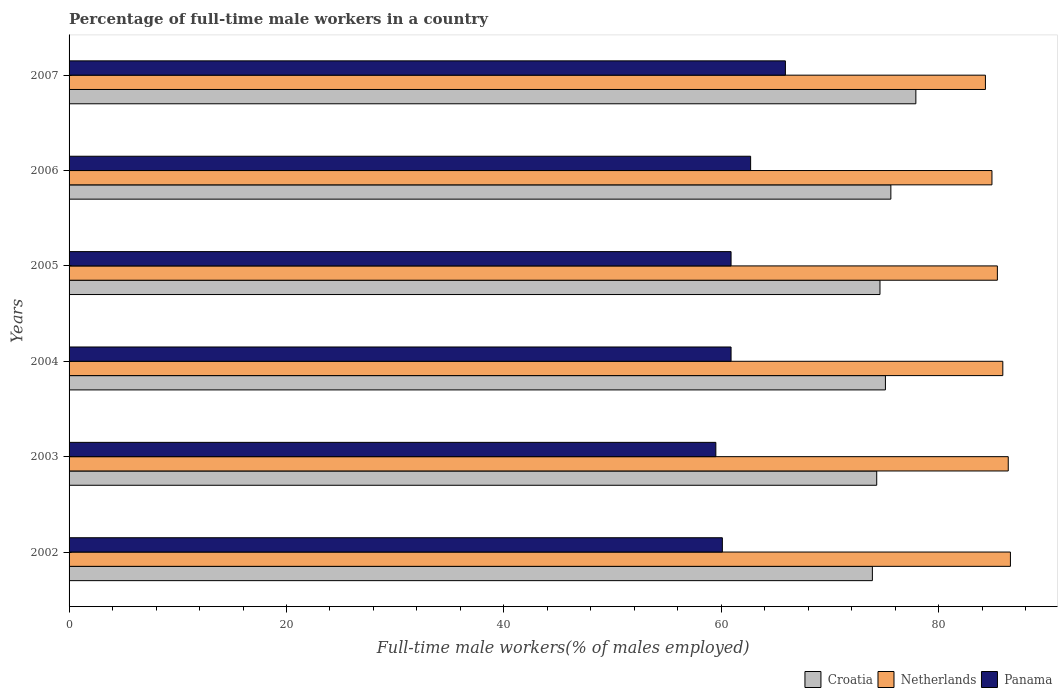How many different coloured bars are there?
Provide a short and direct response. 3. How many groups of bars are there?
Offer a very short reply. 6. Are the number of bars on each tick of the Y-axis equal?
Your answer should be very brief. Yes. How many bars are there on the 4th tick from the bottom?
Offer a terse response. 3. In how many cases, is the number of bars for a given year not equal to the number of legend labels?
Your answer should be compact. 0. What is the percentage of full-time male workers in Croatia in 2006?
Provide a succinct answer. 75.6. Across all years, what is the maximum percentage of full-time male workers in Panama?
Offer a very short reply. 65.9. Across all years, what is the minimum percentage of full-time male workers in Croatia?
Make the answer very short. 73.9. In which year was the percentage of full-time male workers in Netherlands minimum?
Give a very brief answer. 2007. What is the total percentage of full-time male workers in Croatia in the graph?
Your response must be concise. 451.4. What is the difference between the percentage of full-time male workers in Croatia in 2005 and that in 2007?
Your answer should be compact. -3.3. What is the difference between the percentage of full-time male workers in Panama in 2004 and the percentage of full-time male workers in Croatia in 2002?
Your answer should be compact. -13. What is the average percentage of full-time male workers in Croatia per year?
Make the answer very short. 75.23. In the year 2006, what is the difference between the percentage of full-time male workers in Netherlands and percentage of full-time male workers in Panama?
Your answer should be very brief. 22.2. What is the ratio of the percentage of full-time male workers in Panama in 2005 to that in 2006?
Keep it short and to the point. 0.97. Is the difference between the percentage of full-time male workers in Netherlands in 2002 and 2007 greater than the difference between the percentage of full-time male workers in Panama in 2002 and 2007?
Offer a terse response. Yes. What is the difference between the highest and the second highest percentage of full-time male workers in Croatia?
Your response must be concise. 2.3. What is the difference between the highest and the lowest percentage of full-time male workers in Netherlands?
Ensure brevity in your answer.  2.3. What does the 1st bar from the top in 2005 represents?
Your answer should be compact. Panama. What does the 3rd bar from the bottom in 2002 represents?
Your response must be concise. Panama. Is it the case that in every year, the sum of the percentage of full-time male workers in Croatia and percentage of full-time male workers in Panama is greater than the percentage of full-time male workers in Netherlands?
Give a very brief answer. Yes. How many bars are there?
Provide a short and direct response. 18. How many years are there in the graph?
Keep it short and to the point. 6. What is the difference between two consecutive major ticks on the X-axis?
Your answer should be compact. 20. Does the graph contain grids?
Provide a short and direct response. No. How are the legend labels stacked?
Keep it short and to the point. Horizontal. What is the title of the graph?
Ensure brevity in your answer.  Percentage of full-time male workers in a country. What is the label or title of the X-axis?
Provide a succinct answer. Full-time male workers(% of males employed). What is the label or title of the Y-axis?
Provide a succinct answer. Years. What is the Full-time male workers(% of males employed) in Croatia in 2002?
Your answer should be compact. 73.9. What is the Full-time male workers(% of males employed) of Netherlands in 2002?
Your answer should be compact. 86.6. What is the Full-time male workers(% of males employed) in Panama in 2002?
Keep it short and to the point. 60.1. What is the Full-time male workers(% of males employed) in Croatia in 2003?
Your response must be concise. 74.3. What is the Full-time male workers(% of males employed) of Netherlands in 2003?
Ensure brevity in your answer.  86.4. What is the Full-time male workers(% of males employed) of Panama in 2003?
Your response must be concise. 59.5. What is the Full-time male workers(% of males employed) in Croatia in 2004?
Your answer should be very brief. 75.1. What is the Full-time male workers(% of males employed) of Netherlands in 2004?
Give a very brief answer. 85.9. What is the Full-time male workers(% of males employed) in Panama in 2004?
Give a very brief answer. 60.9. What is the Full-time male workers(% of males employed) in Croatia in 2005?
Ensure brevity in your answer.  74.6. What is the Full-time male workers(% of males employed) of Netherlands in 2005?
Give a very brief answer. 85.4. What is the Full-time male workers(% of males employed) in Panama in 2005?
Make the answer very short. 60.9. What is the Full-time male workers(% of males employed) in Croatia in 2006?
Your answer should be very brief. 75.6. What is the Full-time male workers(% of males employed) in Netherlands in 2006?
Your answer should be compact. 84.9. What is the Full-time male workers(% of males employed) of Panama in 2006?
Keep it short and to the point. 62.7. What is the Full-time male workers(% of males employed) of Croatia in 2007?
Ensure brevity in your answer.  77.9. What is the Full-time male workers(% of males employed) of Netherlands in 2007?
Your response must be concise. 84.3. What is the Full-time male workers(% of males employed) of Panama in 2007?
Your answer should be very brief. 65.9. Across all years, what is the maximum Full-time male workers(% of males employed) in Croatia?
Your response must be concise. 77.9. Across all years, what is the maximum Full-time male workers(% of males employed) in Netherlands?
Provide a short and direct response. 86.6. Across all years, what is the maximum Full-time male workers(% of males employed) in Panama?
Your response must be concise. 65.9. Across all years, what is the minimum Full-time male workers(% of males employed) in Croatia?
Your answer should be compact. 73.9. Across all years, what is the minimum Full-time male workers(% of males employed) of Netherlands?
Offer a terse response. 84.3. Across all years, what is the minimum Full-time male workers(% of males employed) of Panama?
Give a very brief answer. 59.5. What is the total Full-time male workers(% of males employed) of Croatia in the graph?
Your answer should be compact. 451.4. What is the total Full-time male workers(% of males employed) of Netherlands in the graph?
Your response must be concise. 513.5. What is the total Full-time male workers(% of males employed) in Panama in the graph?
Give a very brief answer. 370. What is the difference between the Full-time male workers(% of males employed) in Netherlands in 2002 and that in 2004?
Keep it short and to the point. 0.7. What is the difference between the Full-time male workers(% of males employed) of Panama in 2002 and that in 2004?
Your answer should be very brief. -0.8. What is the difference between the Full-time male workers(% of males employed) of Croatia in 2002 and that in 2005?
Your answer should be very brief. -0.7. What is the difference between the Full-time male workers(% of males employed) of Croatia in 2002 and that in 2006?
Ensure brevity in your answer.  -1.7. What is the difference between the Full-time male workers(% of males employed) in Croatia in 2002 and that in 2007?
Your response must be concise. -4. What is the difference between the Full-time male workers(% of males employed) of Netherlands in 2002 and that in 2007?
Your answer should be compact. 2.3. What is the difference between the Full-time male workers(% of males employed) of Panama in 2002 and that in 2007?
Offer a very short reply. -5.8. What is the difference between the Full-time male workers(% of males employed) in Croatia in 2003 and that in 2004?
Keep it short and to the point. -0.8. What is the difference between the Full-time male workers(% of males employed) in Netherlands in 2003 and that in 2004?
Your response must be concise. 0.5. What is the difference between the Full-time male workers(% of males employed) of Panama in 2003 and that in 2005?
Offer a very short reply. -1.4. What is the difference between the Full-time male workers(% of males employed) in Netherlands in 2003 and that in 2007?
Ensure brevity in your answer.  2.1. What is the difference between the Full-time male workers(% of males employed) in Panama in 2003 and that in 2007?
Your answer should be compact. -6.4. What is the difference between the Full-time male workers(% of males employed) of Netherlands in 2004 and that in 2005?
Ensure brevity in your answer.  0.5. What is the difference between the Full-time male workers(% of males employed) of Netherlands in 2004 and that in 2006?
Ensure brevity in your answer.  1. What is the difference between the Full-time male workers(% of males employed) in Netherlands in 2004 and that in 2007?
Provide a succinct answer. 1.6. What is the difference between the Full-time male workers(% of males employed) of Croatia in 2005 and that in 2006?
Provide a succinct answer. -1. What is the difference between the Full-time male workers(% of males employed) of Panama in 2005 and that in 2006?
Your response must be concise. -1.8. What is the difference between the Full-time male workers(% of males employed) in Croatia in 2005 and that in 2007?
Make the answer very short. -3.3. What is the difference between the Full-time male workers(% of males employed) in Croatia in 2006 and that in 2007?
Make the answer very short. -2.3. What is the difference between the Full-time male workers(% of males employed) in Netherlands in 2006 and that in 2007?
Your response must be concise. 0.6. What is the difference between the Full-time male workers(% of males employed) of Croatia in 2002 and the Full-time male workers(% of males employed) of Netherlands in 2003?
Offer a terse response. -12.5. What is the difference between the Full-time male workers(% of males employed) of Netherlands in 2002 and the Full-time male workers(% of males employed) of Panama in 2003?
Keep it short and to the point. 27.1. What is the difference between the Full-time male workers(% of males employed) of Croatia in 2002 and the Full-time male workers(% of males employed) of Netherlands in 2004?
Provide a succinct answer. -12. What is the difference between the Full-time male workers(% of males employed) of Croatia in 2002 and the Full-time male workers(% of males employed) of Panama in 2004?
Ensure brevity in your answer.  13. What is the difference between the Full-time male workers(% of males employed) in Netherlands in 2002 and the Full-time male workers(% of males employed) in Panama in 2004?
Provide a short and direct response. 25.7. What is the difference between the Full-time male workers(% of males employed) in Croatia in 2002 and the Full-time male workers(% of males employed) in Netherlands in 2005?
Your answer should be compact. -11.5. What is the difference between the Full-time male workers(% of males employed) of Netherlands in 2002 and the Full-time male workers(% of males employed) of Panama in 2005?
Your answer should be very brief. 25.7. What is the difference between the Full-time male workers(% of males employed) in Croatia in 2002 and the Full-time male workers(% of males employed) in Panama in 2006?
Offer a very short reply. 11.2. What is the difference between the Full-time male workers(% of males employed) of Netherlands in 2002 and the Full-time male workers(% of males employed) of Panama in 2006?
Keep it short and to the point. 23.9. What is the difference between the Full-time male workers(% of males employed) of Netherlands in 2002 and the Full-time male workers(% of males employed) of Panama in 2007?
Your answer should be compact. 20.7. What is the difference between the Full-time male workers(% of males employed) of Netherlands in 2003 and the Full-time male workers(% of males employed) of Panama in 2004?
Provide a short and direct response. 25.5. What is the difference between the Full-time male workers(% of males employed) of Netherlands in 2003 and the Full-time male workers(% of males employed) of Panama in 2005?
Provide a short and direct response. 25.5. What is the difference between the Full-time male workers(% of males employed) in Croatia in 2003 and the Full-time male workers(% of males employed) in Netherlands in 2006?
Your response must be concise. -10.6. What is the difference between the Full-time male workers(% of males employed) in Croatia in 2003 and the Full-time male workers(% of males employed) in Panama in 2006?
Provide a short and direct response. 11.6. What is the difference between the Full-time male workers(% of males employed) in Netherlands in 2003 and the Full-time male workers(% of males employed) in Panama in 2006?
Provide a short and direct response. 23.7. What is the difference between the Full-time male workers(% of males employed) of Croatia in 2003 and the Full-time male workers(% of males employed) of Netherlands in 2007?
Ensure brevity in your answer.  -10. What is the difference between the Full-time male workers(% of males employed) of Netherlands in 2004 and the Full-time male workers(% of males employed) of Panama in 2005?
Provide a succinct answer. 25. What is the difference between the Full-time male workers(% of males employed) of Croatia in 2004 and the Full-time male workers(% of males employed) of Netherlands in 2006?
Keep it short and to the point. -9.8. What is the difference between the Full-time male workers(% of males employed) of Netherlands in 2004 and the Full-time male workers(% of males employed) of Panama in 2006?
Your answer should be compact. 23.2. What is the difference between the Full-time male workers(% of males employed) of Croatia in 2004 and the Full-time male workers(% of males employed) of Netherlands in 2007?
Your answer should be compact. -9.2. What is the difference between the Full-time male workers(% of males employed) of Netherlands in 2005 and the Full-time male workers(% of males employed) of Panama in 2006?
Provide a succinct answer. 22.7. What is the difference between the Full-time male workers(% of males employed) of Croatia in 2005 and the Full-time male workers(% of males employed) of Panama in 2007?
Offer a very short reply. 8.7. What is the difference between the Full-time male workers(% of males employed) of Netherlands in 2005 and the Full-time male workers(% of males employed) of Panama in 2007?
Make the answer very short. 19.5. What is the difference between the Full-time male workers(% of males employed) in Croatia in 2006 and the Full-time male workers(% of males employed) in Netherlands in 2007?
Your response must be concise. -8.7. What is the difference between the Full-time male workers(% of males employed) of Croatia in 2006 and the Full-time male workers(% of males employed) of Panama in 2007?
Ensure brevity in your answer.  9.7. What is the average Full-time male workers(% of males employed) of Croatia per year?
Offer a very short reply. 75.23. What is the average Full-time male workers(% of males employed) in Netherlands per year?
Your response must be concise. 85.58. What is the average Full-time male workers(% of males employed) in Panama per year?
Offer a terse response. 61.67. In the year 2003, what is the difference between the Full-time male workers(% of males employed) of Croatia and Full-time male workers(% of males employed) of Netherlands?
Offer a very short reply. -12.1. In the year 2003, what is the difference between the Full-time male workers(% of males employed) in Croatia and Full-time male workers(% of males employed) in Panama?
Your response must be concise. 14.8. In the year 2003, what is the difference between the Full-time male workers(% of males employed) in Netherlands and Full-time male workers(% of males employed) in Panama?
Provide a succinct answer. 26.9. In the year 2004, what is the difference between the Full-time male workers(% of males employed) of Croatia and Full-time male workers(% of males employed) of Netherlands?
Give a very brief answer. -10.8. In the year 2004, what is the difference between the Full-time male workers(% of males employed) in Netherlands and Full-time male workers(% of males employed) in Panama?
Your response must be concise. 25. In the year 2005, what is the difference between the Full-time male workers(% of males employed) in Croatia and Full-time male workers(% of males employed) in Panama?
Offer a terse response. 13.7. In the year 2005, what is the difference between the Full-time male workers(% of males employed) of Netherlands and Full-time male workers(% of males employed) of Panama?
Provide a short and direct response. 24.5. In the year 2006, what is the difference between the Full-time male workers(% of males employed) in Netherlands and Full-time male workers(% of males employed) in Panama?
Provide a short and direct response. 22.2. In the year 2007, what is the difference between the Full-time male workers(% of males employed) of Croatia and Full-time male workers(% of males employed) of Panama?
Make the answer very short. 12. In the year 2007, what is the difference between the Full-time male workers(% of males employed) of Netherlands and Full-time male workers(% of males employed) of Panama?
Offer a very short reply. 18.4. What is the ratio of the Full-time male workers(% of males employed) of Netherlands in 2002 to that in 2003?
Your answer should be compact. 1. What is the ratio of the Full-time male workers(% of males employed) of Panama in 2002 to that in 2003?
Offer a very short reply. 1.01. What is the ratio of the Full-time male workers(% of males employed) of Croatia in 2002 to that in 2004?
Make the answer very short. 0.98. What is the ratio of the Full-time male workers(% of males employed) of Panama in 2002 to that in 2004?
Your answer should be compact. 0.99. What is the ratio of the Full-time male workers(% of males employed) in Croatia in 2002 to that in 2005?
Keep it short and to the point. 0.99. What is the ratio of the Full-time male workers(% of males employed) in Netherlands in 2002 to that in 2005?
Keep it short and to the point. 1.01. What is the ratio of the Full-time male workers(% of males employed) of Panama in 2002 to that in 2005?
Your answer should be compact. 0.99. What is the ratio of the Full-time male workers(% of males employed) of Croatia in 2002 to that in 2006?
Make the answer very short. 0.98. What is the ratio of the Full-time male workers(% of males employed) of Panama in 2002 to that in 2006?
Offer a terse response. 0.96. What is the ratio of the Full-time male workers(% of males employed) of Croatia in 2002 to that in 2007?
Give a very brief answer. 0.95. What is the ratio of the Full-time male workers(% of males employed) of Netherlands in 2002 to that in 2007?
Your response must be concise. 1.03. What is the ratio of the Full-time male workers(% of males employed) of Panama in 2002 to that in 2007?
Offer a terse response. 0.91. What is the ratio of the Full-time male workers(% of males employed) in Croatia in 2003 to that in 2004?
Ensure brevity in your answer.  0.99. What is the ratio of the Full-time male workers(% of males employed) of Panama in 2003 to that in 2004?
Provide a short and direct response. 0.98. What is the ratio of the Full-time male workers(% of males employed) of Netherlands in 2003 to that in 2005?
Offer a terse response. 1.01. What is the ratio of the Full-time male workers(% of males employed) of Panama in 2003 to that in 2005?
Offer a terse response. 0.98. What is the ratio of the Full-time male workers(% of males employed) of Croatia in 2003 to that in 2006?
Your response must be concise. 0.98. What is the ratio of the Full-time male workers(% of males employed) of Netherlands in 2003 to that in 2006?
Your answer should be compact. 1.02. What is the ratio of the Full-time male workers(% of males employed) of Panama in 2003 to that in 2006?
Your response must be concise. 0.95. What is the ratio of the Full-time male workers(% of males employed) of Croatia in 2003 to that in 2007?
Make the answer very short. 0.95. What is the ratio of the Full-time male workers(% of males employed) in Netherlands in 2003 to that in 2007?
Your answer should be compact. 1.02. What is the ratio of the Full-time male workers(% of males employed) of Panama in 2003 to that in 2007?
Offer a terse response. 0.9. What is the ratio of the Full-time male workers(% of males employed) in Netherlands in 2004 to that in 2005?
Your response must be concise. 1.01. What is the ratio of the Full-time male workers(% of males employed) of Panama in 2004 to that in 2005?
Ensure brevity in your answer.  1. What is the ratio of the Full-time male workers(% of males employed) of Croatia in 2004 to that in 2006?
Offer a very short reply. 0.99. What is the ratio of the Full-time male workers(% of males employed) in Netherlands in 2004 to that in 2006?
Your answer should be very brief. 1.01. What is the ratio of the Full-time male workers(% of males employed) in Panama in 2004 to that in 2006?
Your response must be concise. 0.97. What is the ratio of the Full-time male workers(% of males employed) of Croatia in 2004 to that in 2007?
Ensure brevity in your answer.  0.96. What is the ratio of the Full-time male workers(% of males employed) in Panama in 2004 to that in 2007?
Your answer should be compact. 0.92. What is the ratio of the Full-time male workers(% of males employed) in Croatia in 2005 to that in 2006?
Your answer should be compact. 0.99. What is the ratio of the Full-time male workers(% of males employed) of Netherlands in 2005 to that in 2006?
Make the answer very short. 1.01. What is the ratio of the Full-time male workers(% of males employed) of Panama in 2005 to that in 2006?
Make the answer very short. 0.97. What is the ratio of the Full-time male workers(% of males employed) in Croatia in 2005 to that in 2007?
Ensure brevity in your answer.  0.96. What is the ratio of the Full-time male workers(% of males employed) in Panama in 2005 to that in 2007?
Your answer should be very brief. 0.92. What is the ratio of the Full-time male workers(% of males employed) of Croatia in 2006 to that in 2007?
Offer a terse response. 0.97. What is the ratio of the Full-time male workers(% of males employed) in Netherlands in 2006 to that in 2007?
Your response must be concise. 1.01. What is the ratio of the Full-time male workers(% of males employed) in Panama in 2006 to that in 2007?
Your response must be concise. 0.95. What is the difference between the highest and the second highest Full-time male workers(% of males employed) of Croatia?
Keep it short and to the point. 2.3. What is the difference between the highest and the second highest Full-time male workers(% of males employed) in Netherlands?
Offer a very short reply. 0.2. What is the difference between the highest and the second highest Full-time male workers(% of males employed) in Panama?
Provide a short and direct response. 3.2. What is the difference between the highest and the lowest Full-time male workers(% of males employed) of Netherlands?
Your answer should be very brief. 2.3. What is the difference between the highest and the lowest Full-time male workers(% of males employed) in Panama?
Your answer should be compact. 6.4. 